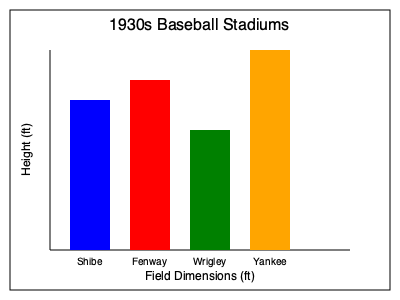Based on the graph showing the field dimensions of four famous 1930s baseball stadiums, which stadium had the shortest overall height? To determine which stadium had the shortest overall height, we need to compare the heights of the bars representing each stadium:

1. Shibe Park (blue bar): Approximately 150 units tall
2. Fenway Park (red bar): Approximately 170 units tall
3. Wrigley Field (green bar): Approximately 120 units tall
4. Yankee Stadium (orange bar): Approximately 200 units tall

Comparing these heights, we can see that Wrigley Field has the shortest bar, representing the lowest overall height among the four stadiums shown.
Answer: Wrigley Field 